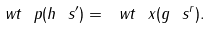<formula> <loc_0><loc_0><loc_500><loc_500>\ w t \ p ( h \ s ^ { \prime } ) = \ w t \ x ( g \ s ^ { r } ) .</formula> 